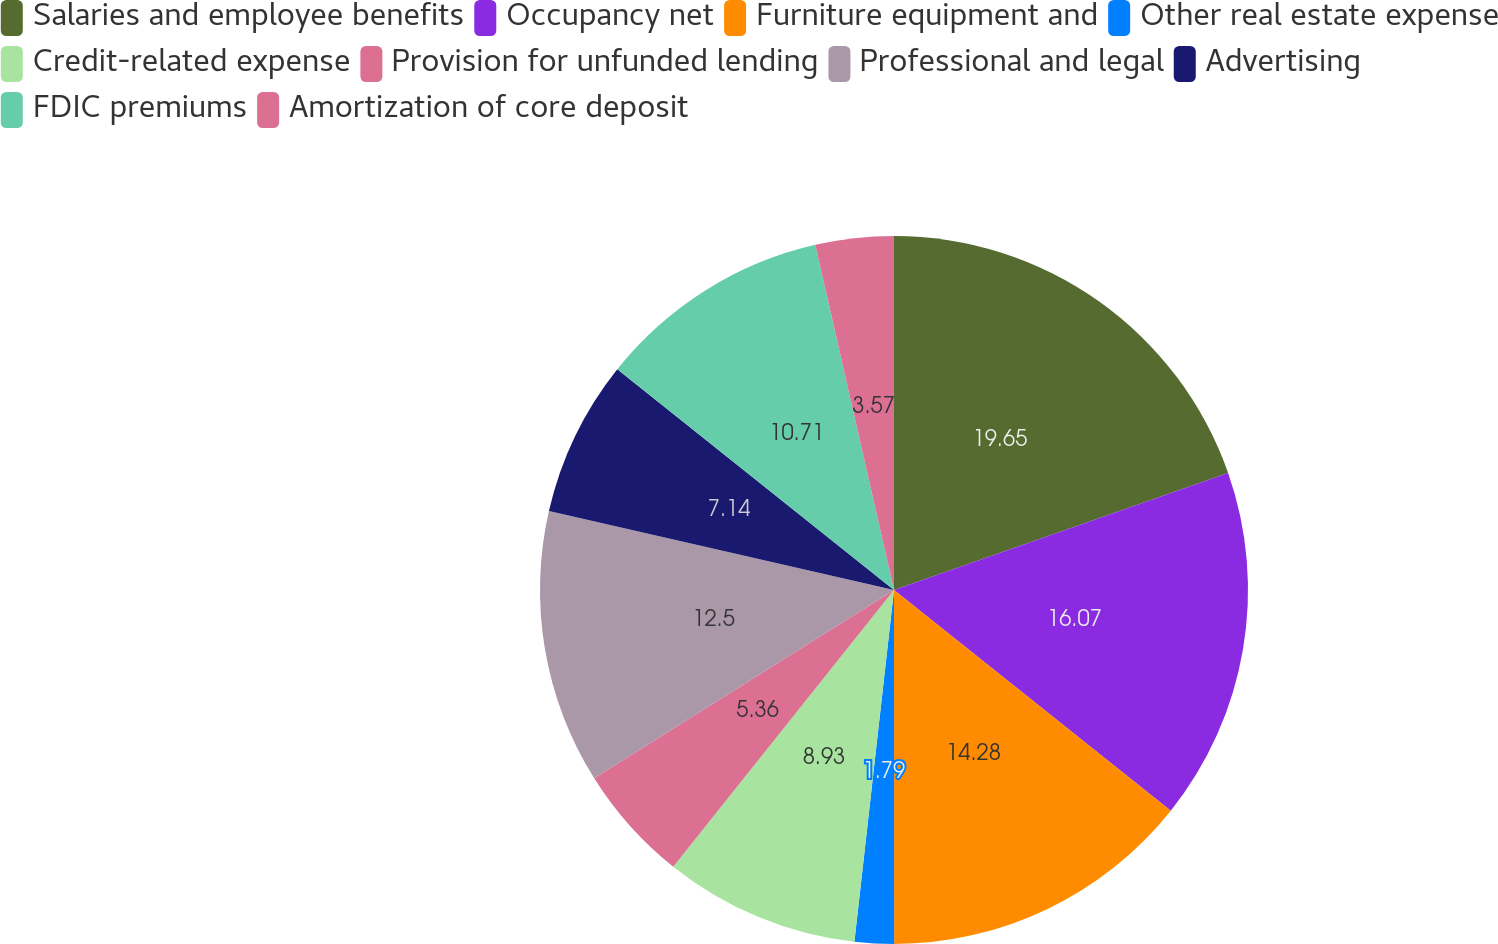Convert chart to OTSL. <chart><loc_0><loc_0><loc_500><loc_500><pie_chart><fcel>Salaries and employee benefits<fcel>Occupancy net<fcel>Furniture equipment and<fcel>Other real estate expense<fcel>Credit-related expense<fcel>Provision for unfunded lending<fcel>Professional and legal<fcel>Advertising<fcel>FDIC premiums<fcel>Amortization of core deposit<nl><fcel>19.64%<fcel>16.07%<fcel>14.28%<fcel>1.79%<fcel>8.93%<fcel>5.36%<fcel>12.5%<fcel>7.14%<fcel>10.71%<fcel>3.57%<nl></chart> 